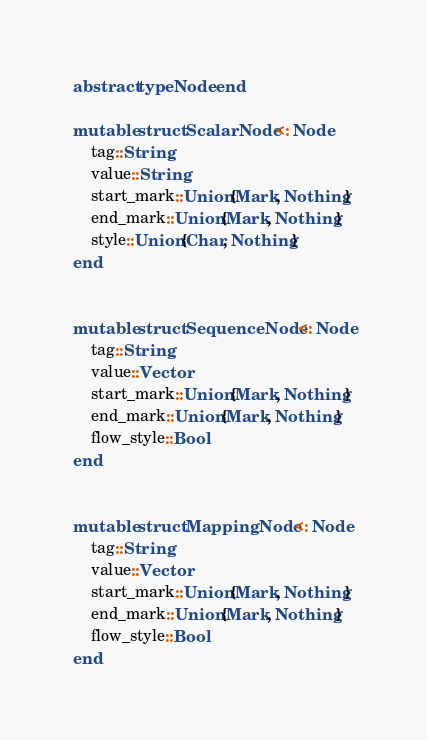<code> <loc_0><loc_0><loc_500><loc_500><_Julia_>
abstract type Node end

mutable struct ScalarNode <: Node
    tag::String
    value::String
    start_mark::Union{Mark, Nothing}
    end_mark::Union{Mark, Nothing}
    style::Union{Char, Nothing}
end


mutable struct SequenceNode <: Node
    tag::String
    value::Vector
    start_mark::Union{Mark, Nothing}
    end_mark::Union{Mark, Nothing}
    flow_style::Bool
end


mutable struct MappingNode <: Node
    tag::String
    value::Vector
    start_mark::Union{Mark, Nothing}
    end_mark::Union{Mark, Nothing}
    flow_style::Bool
end
</code> 